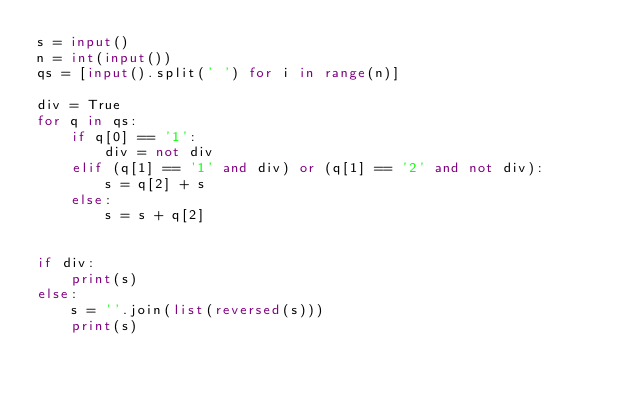<code> <loc_0><loc_0><loc_500><loc_500><_Python_>s = input()
n = int(input())
qs = [input().split(' ') for i in range(n)]

div = True
for q in qs:
    if q[0] == '1':
        div = not div
    elif (q[1] == '1' and div) or (q[1] == '2' and not div):
        s = q[2] + s
    else:
        s = s + q[2]


if div:
    print(s)
else:
    s = ''.join(list(reversed(s)))
    print(s)
</code> 